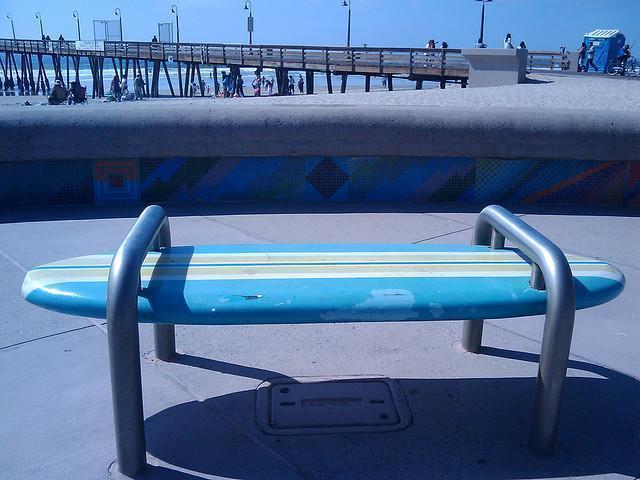What are the bars touching in the foreground?
Answer the question by selecting the correct answer among the 4 following choices.
Options: Baby, apple, surf board, cow. Surf board. 